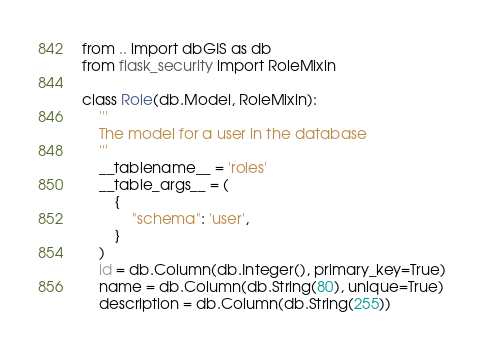Convert code to text. <code><loc_0><loc_0><loc_500><loc_500><_Python_>from .. import dbGIS as db
from flask_security import RoleMixin

class Role(db.Model, RoleMixin):
    '''
    The model for a user in the database
    '''
    __tablename__ = 'roles'
    __table_args__ = (
        {
            "schema": 'user',
        }
    )
    id = db.Column(db.Integer(), primary_key=True)
    name = db.Column(db.String(80), unique=True)
    description = db.Column(db.String(255))

</code> 